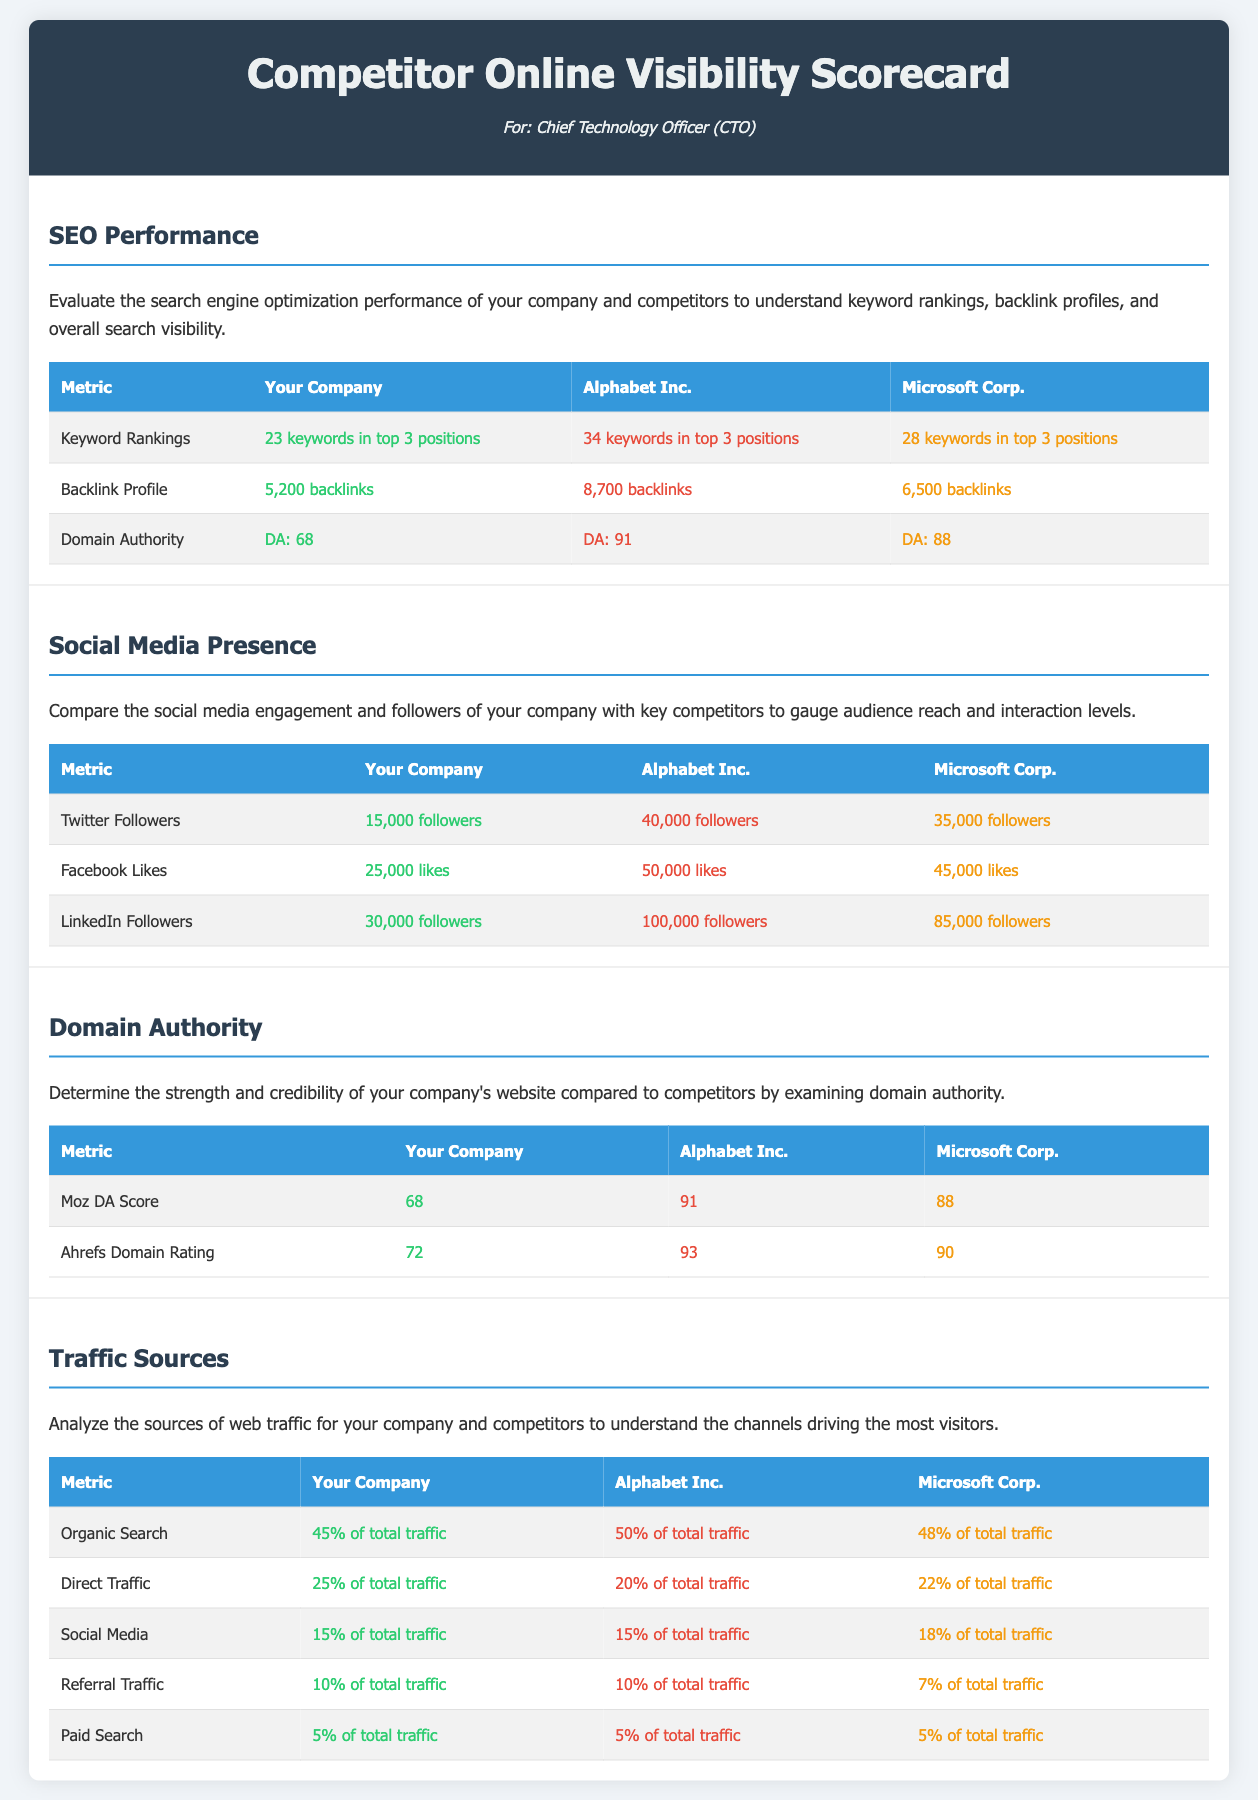What is the number of keywords in top 3 positions for your company? Your company has 23 keywords in top 3 positions as per the SEO performance metrics.
Answer: 23 keywords How many backlinks does Alphabet Inc. have? Alphabet Inc. has 8,700 backlinks based on the backlink profile in the document.
Answer: 8,700 backlinks What is the Domain Authority (DA) of Microsoft Corp.? Microsoft Corp. has a Domain Authority of 88, as mentioned in the SEO performance section.
Answer: DA: 88 Which social media metric has the highest value for your company? The LinkedIn Followers metric is highest for your company with 30,000 followers.
Answer: 30,000 followers What percentage of total traffic for your company comes from Organic Search? Your company has 45% of its total traffic coming from Organic Search as indicated in the traffic sources section.
Answer: 45% of total traffic Which competitor has the highest Twitter Followers? A comparison in the social media presence section shows that Alphabet Inc. has the highest Twitter followers.
Answer: 40,000 followers How many Facebook Likes does your company have? The document specifies that your company has 25,000 Facebook Likes in the social media presence section.
Answer: 25,000 likes Which company has the highest Ahrefs Domain Rating? Based on the Domain Authority section, Alphabet Inc. has the highest Ahrefs Domain Rating of 93.
Answer: 93 What is your company's market share of Direct Traffic? Your company has a market share of 25% of total traffic for Direct Traffic.
Answer: 25% of total traffic 